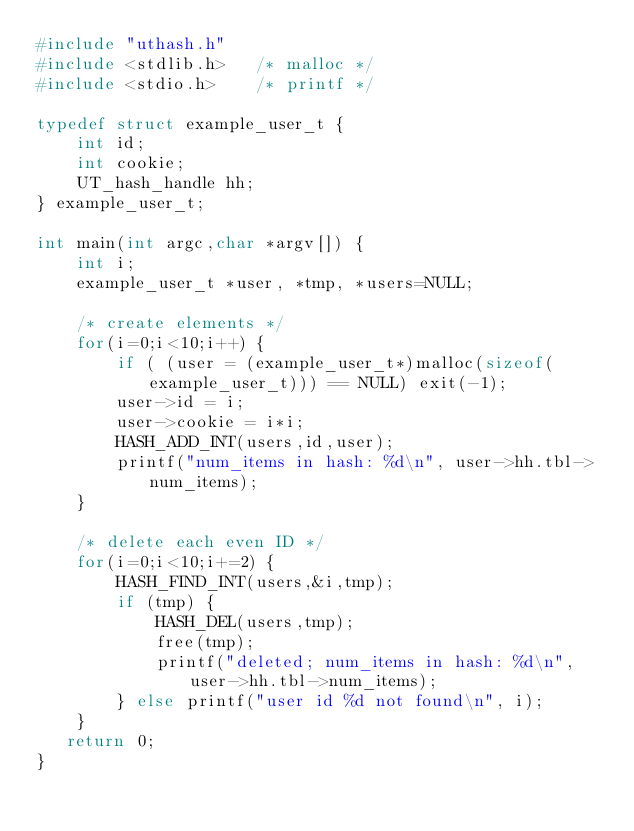Convert code to text. <code><loc_0><loc_0><loc_500><loc_500><_C_>#include "uthash.h"
#include <stdlib.h>   /* malloc */
#include <stdio.h>    /* printf */

typedef struct example_user_t {
    int id;
    int cookie;
    UT_hash_handle hh;
} example_user_t;

int main(int argc,char *argv[]) {
    int i;
    example_user_t *user, *tmp, *users=NULL;

    /* create elements */
    for(i=0;i<10;i++) {
        if ( (user = (example_user_t*)malloc(sizeof(example_user_t))) == NULL) exit(-1);
        user->id = i;
        user->cookie = i*i;
        HASH_ADD_INT(users,id,user);
        printf("num_items in hash: %d\n", user->hh.tbl->num_items);
    }

    /* delete each even ID */
    for(i=0;i<10;i+=2) {
        HASH_FIND_INT(users,&i,tmp);
        if (tmp) {
            HASH_DEL(users,tmp);
            free(tmp);
            printf("deleted; num_items in hash: %d\n", user->hh.tbl->num_items);
        } else printf("user id %d not found\n", i);
    }
   return 0;
}
</code> 